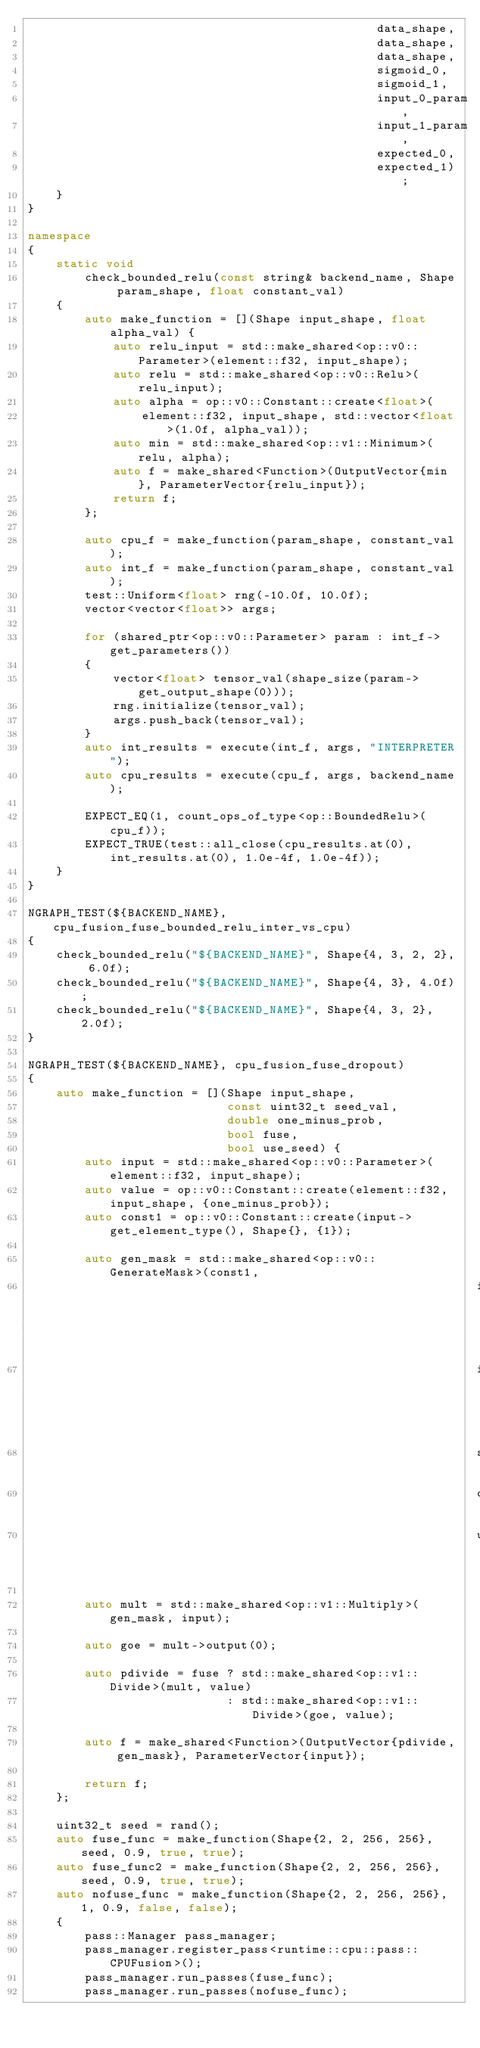Convert code to text. <code><loc_0><loc_0><loc_500><loc_500><_C++_>                                                 data_shape,
                                                 data_shape,
                                                 data_shape,
                                                 sigmoid_0,
                                                 sigmoid_1,
                                                 input_0_param,
                                                 input_1_param,
                                                 expected_0,
                                                 expected_1);
    }
}

namespace
{
    static void
        check_bounded_relu(const string& backend_name, Shape param_shape, float constant_val)
    {
        auto make_function = [](Shape input_shape, float alpha_val) {
            auto relu_input = std::make_shared<op::v0::Parameter>(element::f32, input_shape);
            auto relu = std::make_shared<op::v0::Relu>(relu_input);
            auto alpha = op::v0::Constant::create<float>(
                element::f32, input_shape, std::vector<float>(1.0f, alpha_val));
            auto min = std::make_shared<op::v1::Minimum>(relu, alpha);
            auto f = make_shared<Function>(OutputVector{min}, ParameterVector{relu_input});
            return f;
        };

        auto cpu_f = make_function(param_shape, constant_val);
        auto int_f = make_function(param_shape, constant_val);
        test::Uniform<float> rng(-10.0f, 10.0f);
        vector<vector<float>> args;

        for (shared_ptr<op::v0::Parameter> param : int_f->get_parameters())
        {
            vector<float> tensor_val(shape_size(param->get_output_shape(0)));
            rng.initialize(tensor_val);
            args.push_back(tensor_val);
        }
        auto int_results = execute(int_f, args, "INTERPRETER");
        auto cpu_results = execute(cpu_f, args, backend_name);

        EXPECT_EQ(1, count_ops_of_type<op::BoundedRelu>(cpu_f));
        EXPECT_TRUE(test::all_close(cpu_results.at(0), int_results.at(0), 1.0e-4f, 1.0e-4f));
    }
}

NGRAPH_TEST(${BACKEND_NAME}, cpu_fusion_fuse_bounded_relu_inter_vs_cpu)
{
    check_bounded_relu("${BACKEND_NAME}", Shape{4, 3, 2, 2}, 6.0f);
    check_bounded_relu("${BACKEND_NAME}", Shape{4, 3}, 4.0f);
    check_bounded_relu("${BACKEND_NAME}", Shape{4, 3, 2}, 2.0f);
}

NGRAPH_TEST(${BACKEND_NAME}, cpu_fusion_fuse_dropout)
{
    auto make_function = [](Shape input_shape,
                            const uint32_t seed_val,
                            double one_minus_prob,
                            bool fuse,
                            bool use_seed) {
        auto input = std::make_shared<op::v0::Parameter>(element::f32, input_shape);
        auto value = op::v0::Constant::create(element::f32, input_shape, {one_minus_prob});
        auto const1 = op::v0::Constant::create(input->get_element_type(), Shape{}, {1});

        auto gen_mask = std::make_shared<op::v0::GenerateMask>(const1,
                                                               input->get_output_shape(0),
                                                               input->get_element_type(),
                                                               seed_val,
                                                               one_minus_prob,
                                                               use_seed);

        auto mult = std::make_shared<op::v1::Multiply>(gen_mask, input);

        auto goe = mult->output(0);

        auto pdivide = fuse ? std::make_shared<op::v1::Divide>(mult, value)
                            : std::make_shared<op::v1::Divide>(goe, value);

        auto f = make_shared<Function>(OutputVector{pdivide, gen_mask}, ParameterVector{input});

        return f;
    };

    uint32_t seed = rand();
    auto fuse_func = make_function(Shape{2, 2, 256, 256}, seed, 0.9, true, true);
    auto fuse_func2 = make_function(Shape{2, 2, 256, 256}, seed, 0.9, true, true);
    auto nofuse_func = make_function(Shape{2, 2, 256, 256}, 1, 0.9, false, false);
    {
        pass::Manager pass_manager;
        pass_manager.register_pass<runtime::cpu::pass::CPUFusion>();
        pass_manager.run_passes(fuse_func);
        pass_manager.run_passes(nofuse_func);</code> 